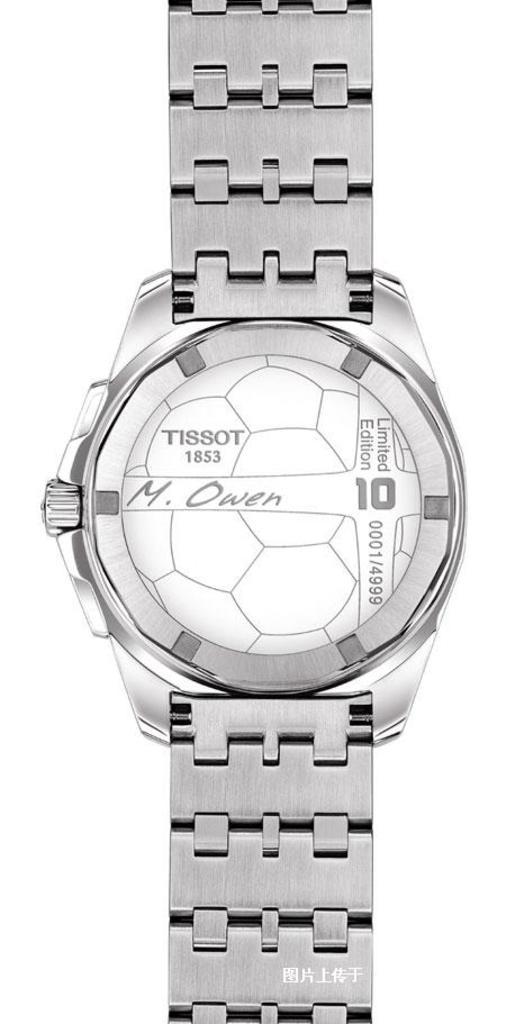What is the name on the wach?
Make the answer very short. M. owen. 